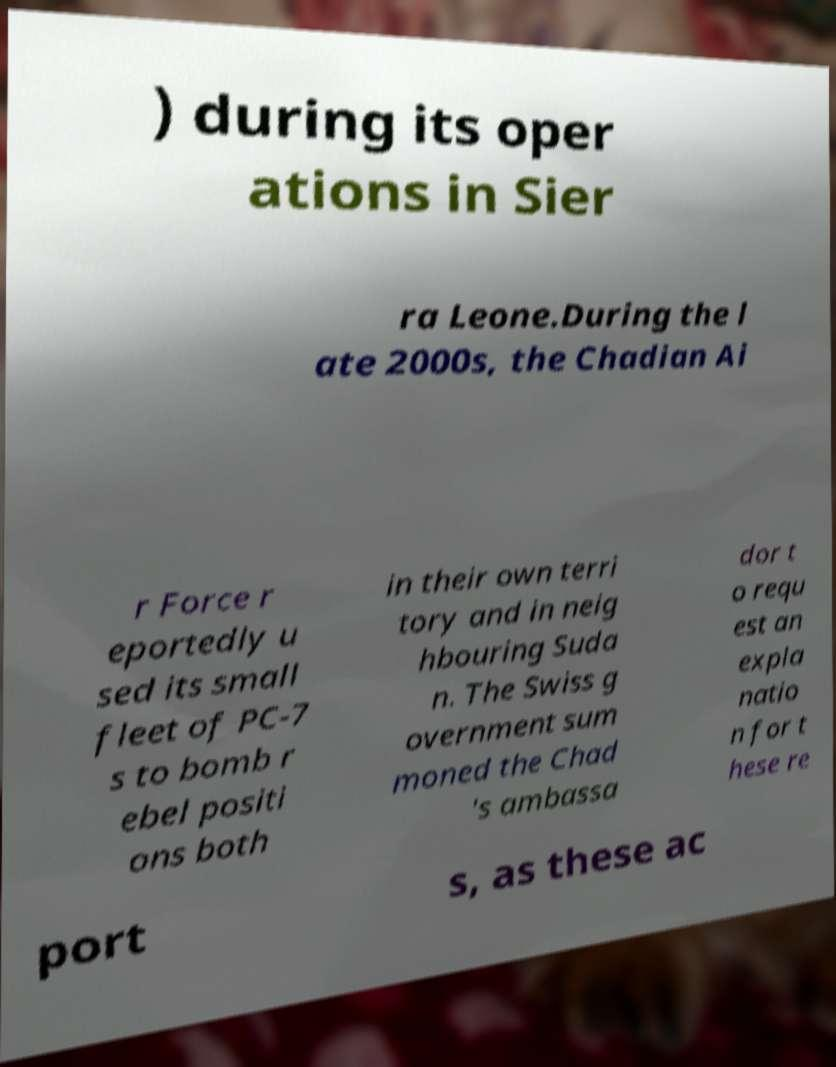What messages or text are displayed in this image? I need them in a readable, typed format. ) during its oper ations in Sier ra Leone.During the l ate 2000s, the Chadian Ai r Force r eportedly u sed its small fleet of PC-7 s to bomb r ebel positi ons both in their own terri tory and in neig hbouring Suda n. The Swiss g overnment sum moned the Chad 's ambassa dor t o requ est an expla natio n for t hese re port s, as these ac 